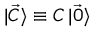<formula> <loc_0><loc_0><loc_500><loc_500>\ m a t h i n n e r { | { \vec { C } } \rangle } \equiv C \ m a t h i n n e r { | { \vec { 0 } } \rangle }</formula> 